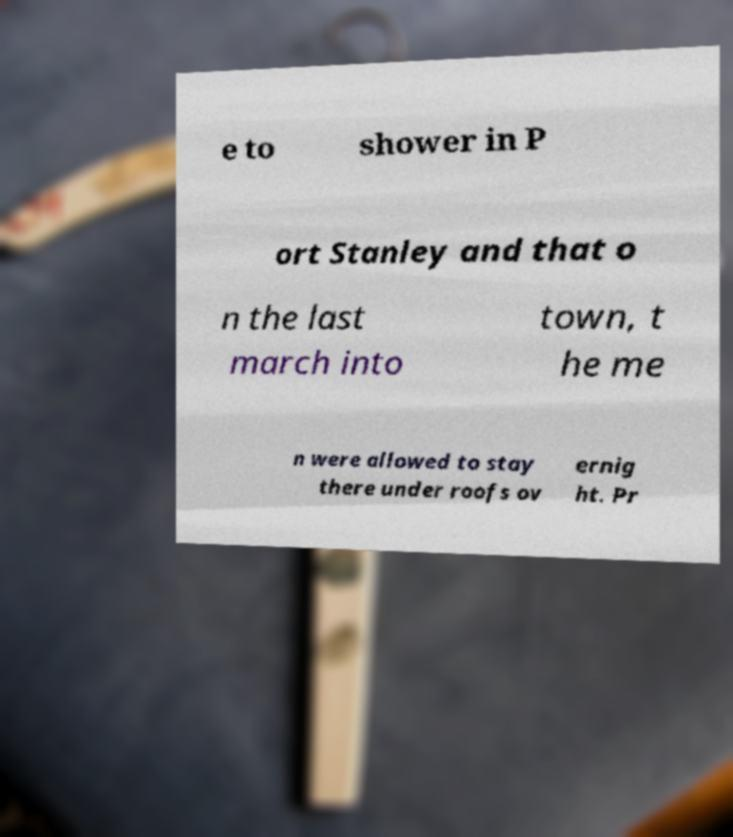Please identify and transcribe the text found in this image. e to shower in P ort Stanley and that o n the last march into town, t he me n were allowed to stay there under roofs ov ernig ht. Pr 